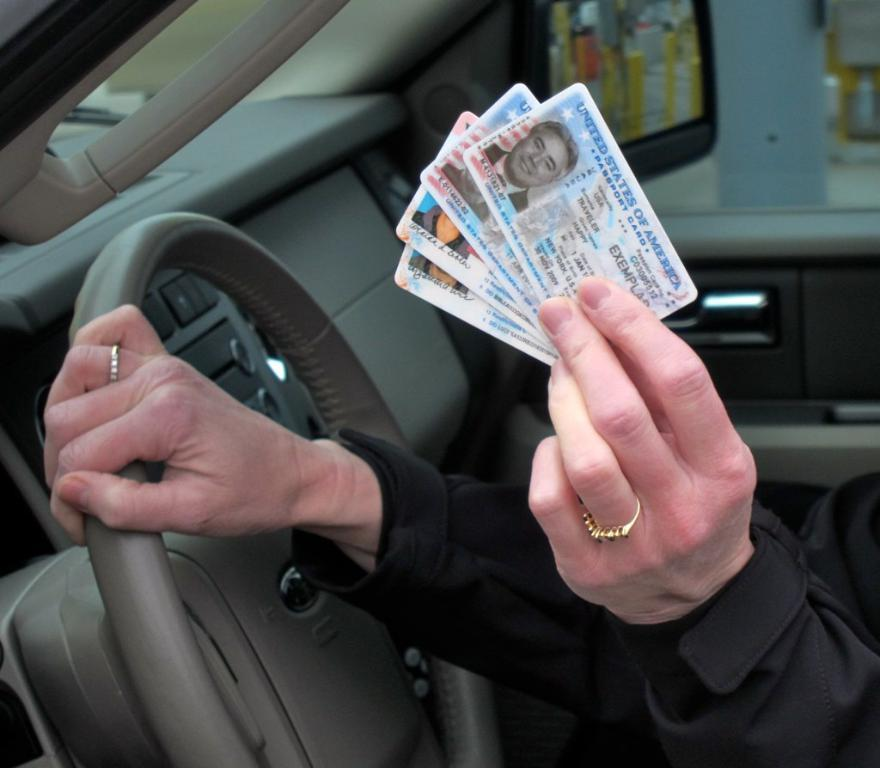What objects are being held in the image? There are hands holding cards in the image. What vehicle-related object is present in the image? There is a steering wheel in the image. What type of window is visible in the image? There is a glass window in the image. What can be seen through the glass window? A side mirror is visible through the glass window. What type of wood can be seen in the image? There is no wood present in the image. How many snakes are slithering on the steering wheel in the image? There are no snakes present in the image; only a steering wheel is visible. 